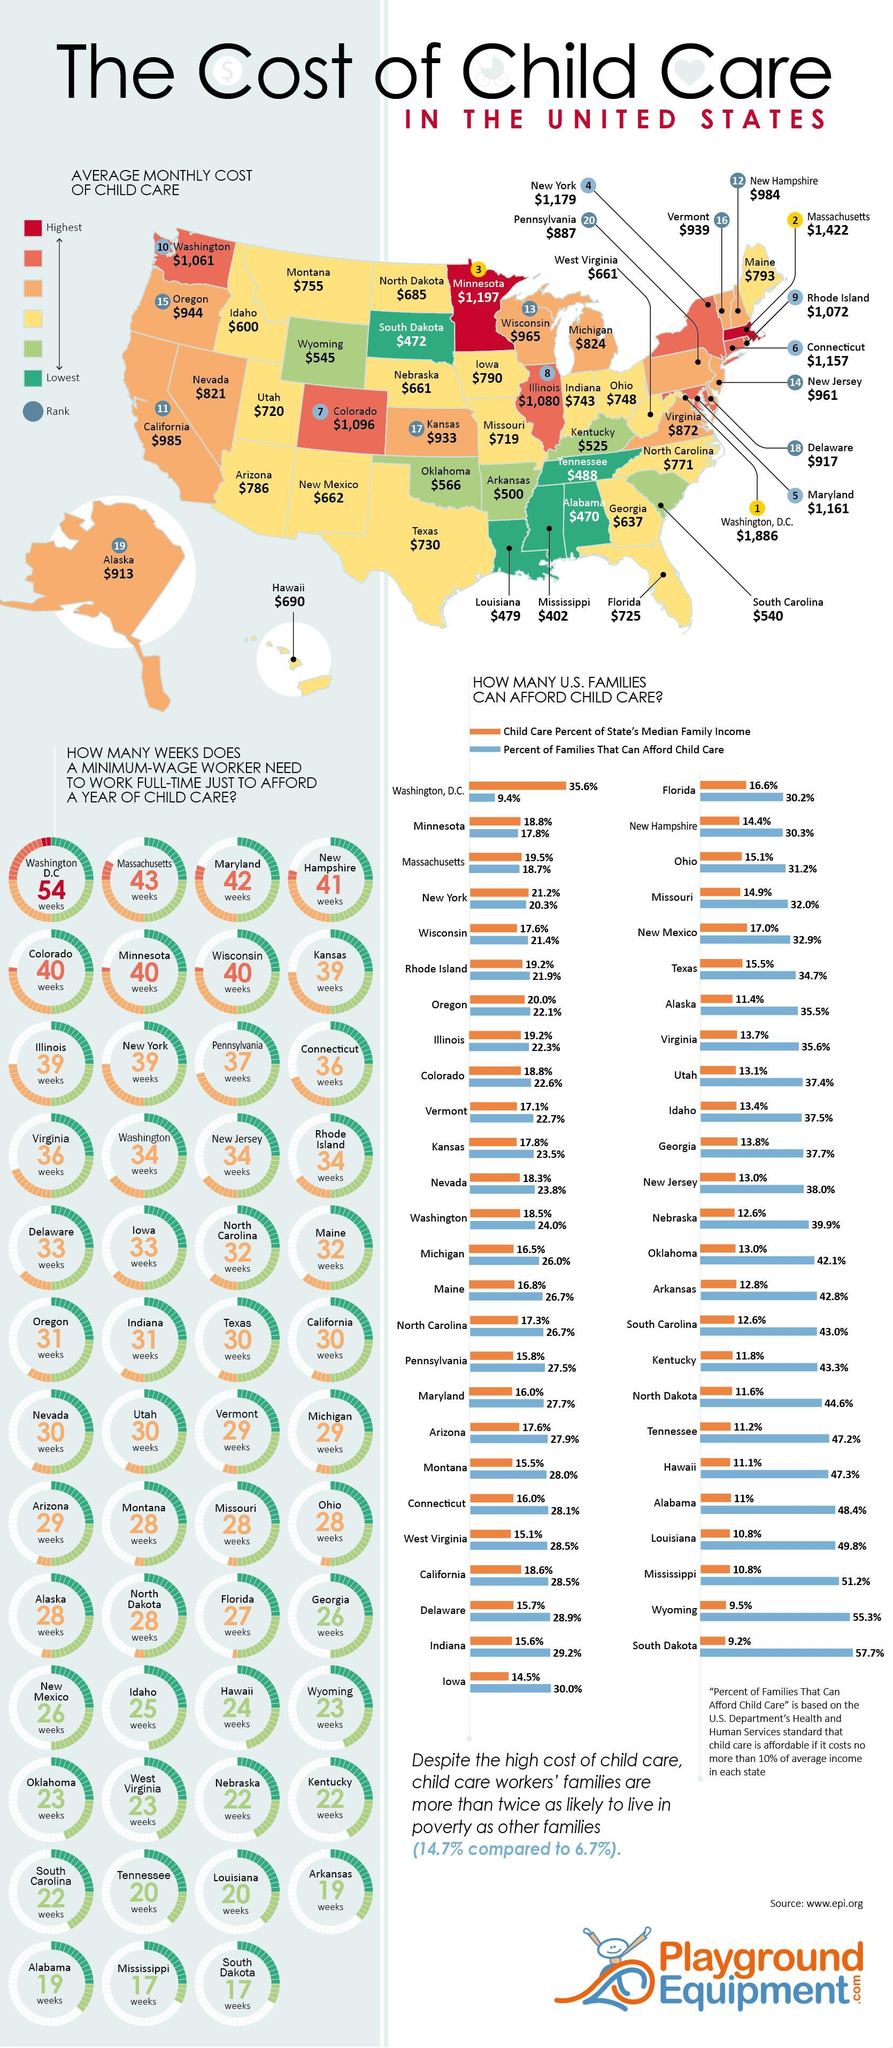How many states have the highest average monthly cost of child care?
Answer the question with a short phrase. 2 How many states have the second-lowest average monthly cost of child care? 5 What is the difference between the percent of families that can afford child care in Michigan and Nevada, taken together? 2.2% How many states have the lowest average monthly cost of child care? 5 What is the difference between the percent of families that can afford child care in Ohio and Florida, taken together? 1% 